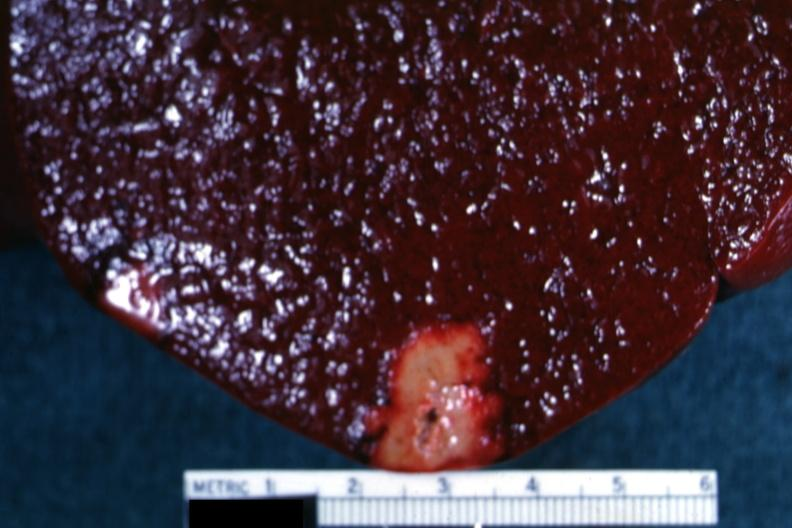does this image show yellow infarct with band of reactive hyperemia?
Answer the question using a single word or phrase. Yes 